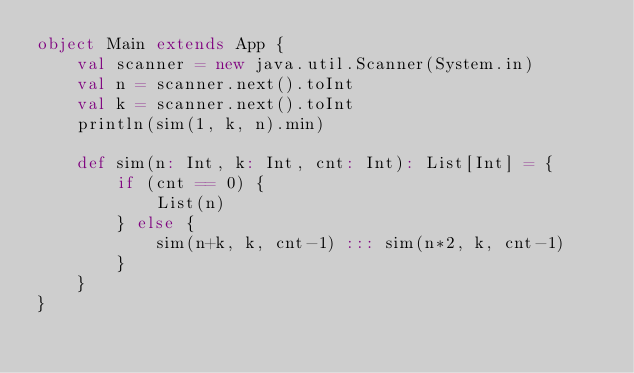<code> <loc_0><loc_0><loc_500><loc_500><_Scala_>object Main extends App {
    val scanner = new java.util.Scanner(System.in)
    val n = scanner.next().toInt
    val k = scanner.next().toInt
    println(sim(1, k, n).min)
    
    def sim(n: Int, k: Int, cnt: Int): List[Int] = {
        if (cnt == 0) { 
            List(n)
        } else {
            sim(n+k, k, cnt-1) ::: sim(n*2, k, cnt-1)
        }
    }
}</code> 